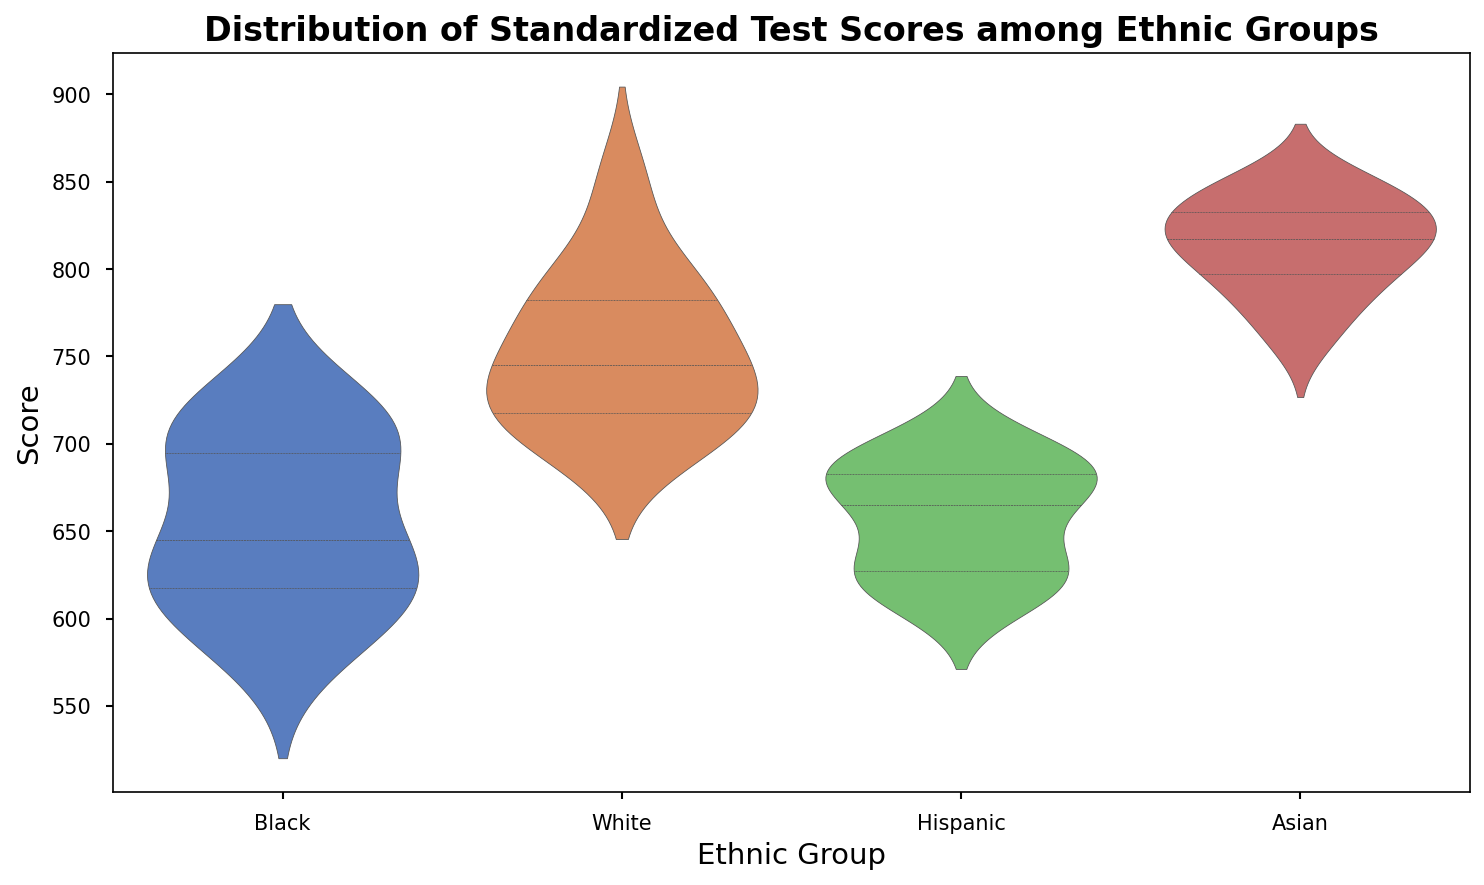What is the median score for Black students? The median is the middle value of the dataset. When you arrange the scores of Black students in ascending order (580, 600, 610, 620, 630, 640, 650, 690, 690, 710, 720, 720), the median is the average of the 6th and 7th points (640 and 650). Therefore, (640 + 650)/2 = 645.
Answer: 645 Which ethnic group has the highest median test score? By visually inspecting the violins, we can see the median white lines. The Asian group has the highest median, situated at around 820.
Answer: Asian What is the interquartile range (IQR) for Hispanic students? The IQR is calculated as Q3 (75th percentile) minus Q1 (25th percentile). For Hispanic students, visually estimating from the quartile lines inside the violin plot, Q1 is around 620 and Q3 is around 680. Thus, the IQR is 680 - 620 = 60.
Answer: 60 Which group's scores have the widest distribution? The width of the violins shows the distribution of scores. The Black group's violin seems widest at the top, indicating a broader range.
Answer: Black Which groups have a higher median than the group with the lowest median? The Black group has the lowest median. Therefore, comparing the other groups, each (Hispanic, White, and Asian) has a higher median than the Black group.
Answer: Hispanic, White, Asian Which ethnic group has the least variation in scores? The tightest (most narrow) violin plot indicates the least variation. The White group's violin is narrower compared to others, indicating less variation.
Answer: White What is the approximate range of test scores for Asian students? The range is the difference between the highest and lowest score. From the plot, the scores range from about 760 to 850. Thus, the range is 850 - 760 = 90.
Answer: 90 Among White and Hispanic students, which group shows a higher peak density of scores around the median? The bulge in the violin plots around the median indicates peak density. The Hispanic group shows a higher peak density around the median compared to the White group, seen by a thicker waist.
Answer: Hispanic What proportion of Hispanic students have scores below 660? Observing the distribution of the violin, approximately 25% of scores lie below the Q1 value of about 660.
Answer: 25% Comparing Black and White students, which group has a higher variation within the interquartile range? The interquartile width (middle area) shows the variation in this range. The Black group's middle range is wider compared to White's, indicating higher variation.
Answer: Black 